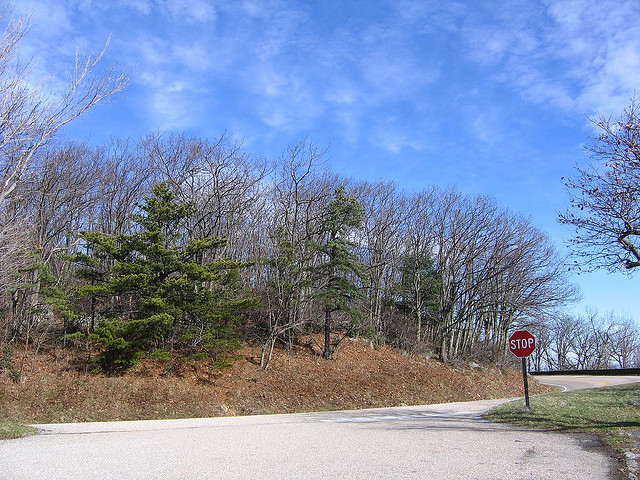Could you tell me about the type of vegetation seen beside the road? Alongside the road, there's a mix of green evergreens and leaf-bare deciduous trees, typical of temperate broadleaf forests. 